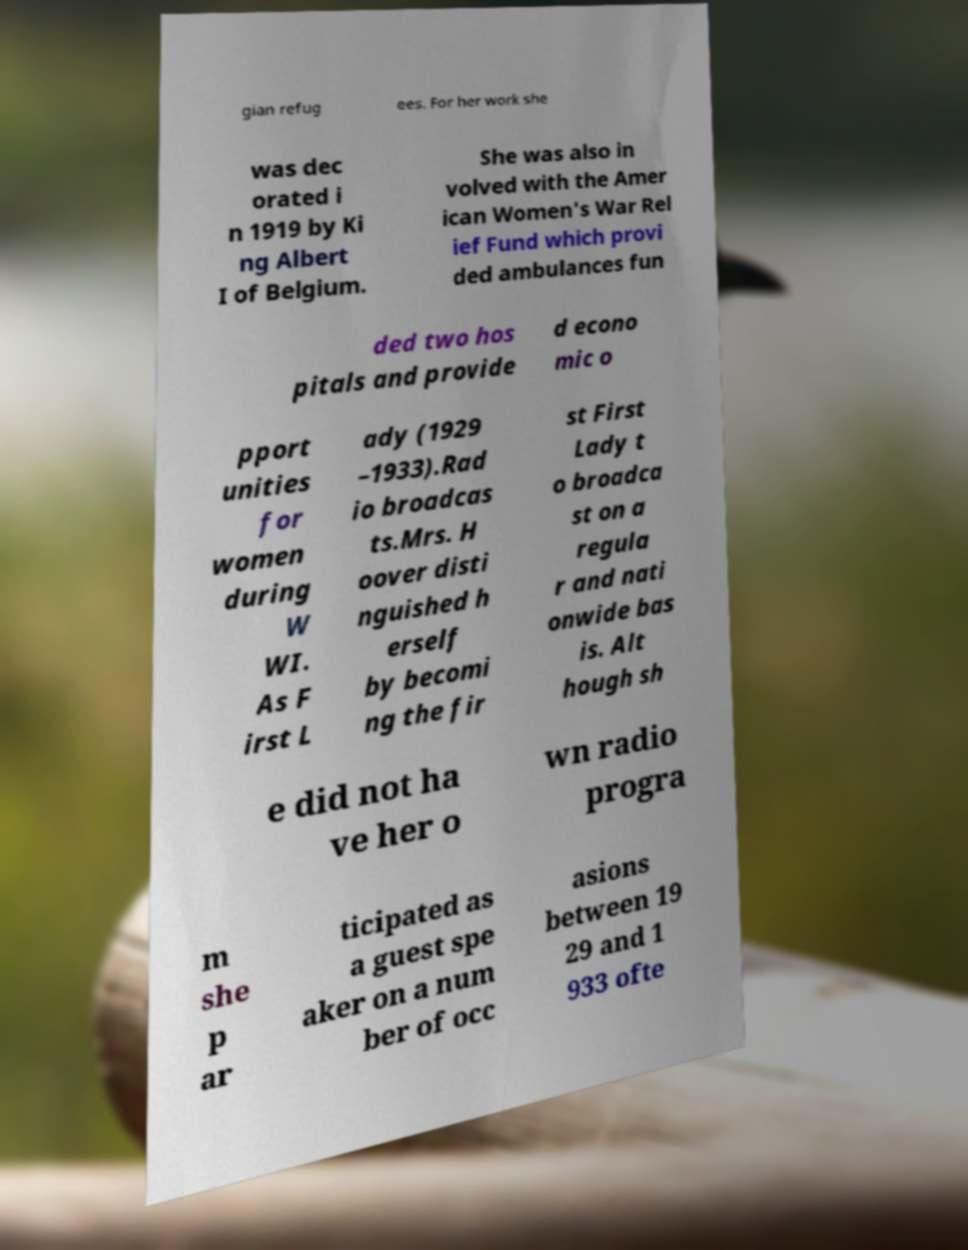Could you extract and type out the text from this image? gian refug ees. For her work she was dec orated i n 1919 by Ki ng Albert I of Belgium. She was also in volved with the Amer ican Women's War Rel ief Fund which provi ded ambulances fun ded two hos pitals and provide d econo mic o pport unities for women during W WI. As F irst L ady (1929 –1933).Rad io broadcas ts.Mrs. H oover disti nguished h erself by becomi ng the fir st First Lady t o broadca st on a regula r and nati onwide bas is. Alt hough sh e did not ha ve her o wn radio progra m she p ar ticipated as a guest spe aker on a num ber of occ asions between 19 29 and 1 933 ofte 